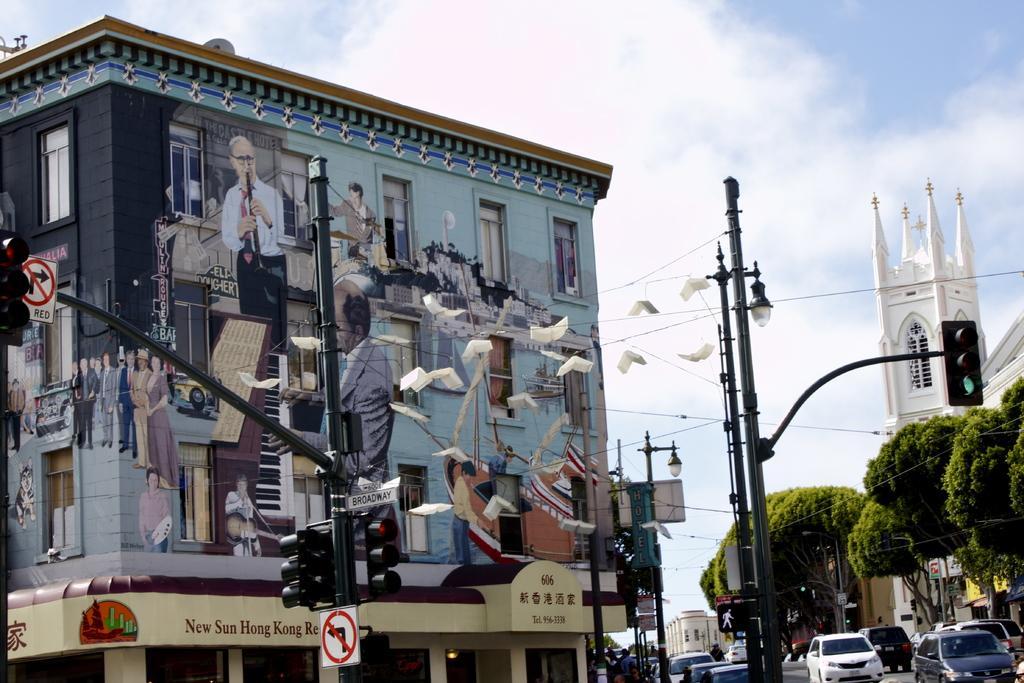Please provide a concise description of this image. In this image in the front there is a pole with some sign board on it. In the background there are buildings, trees, poles and there are cars on the road and the sky is cloudy. 